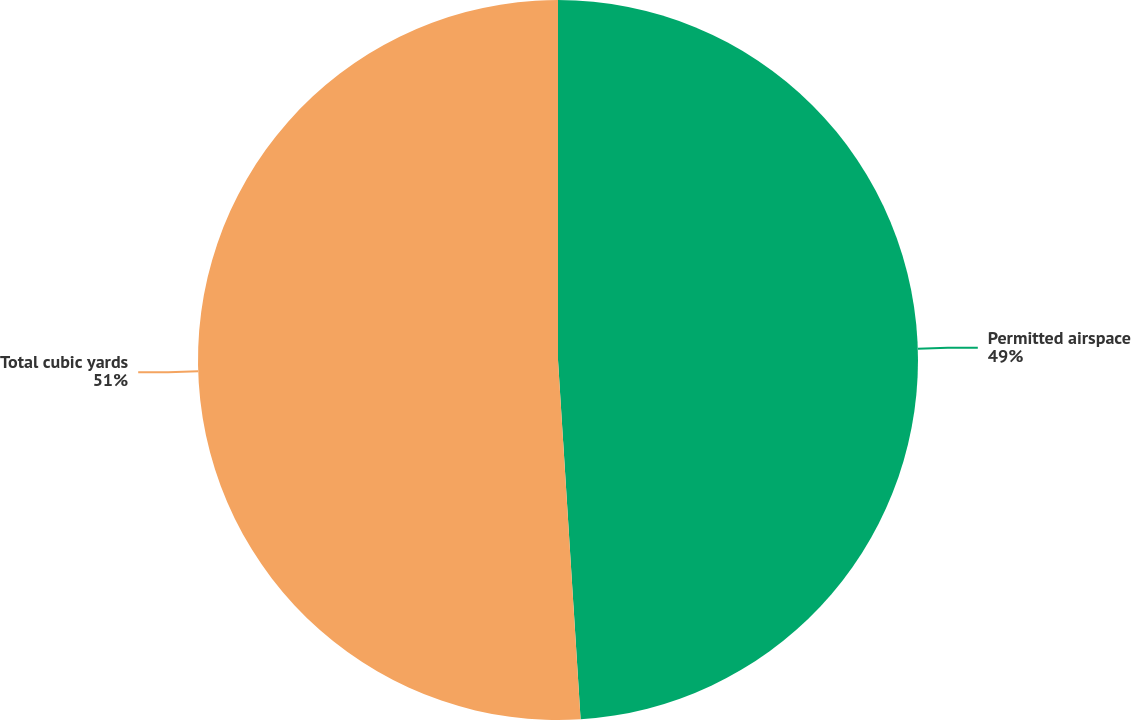Convert chart to OTSL. <chart><loc_0><loc_0><loc_500><loc_500><pie_chart><fcel>Permitted airspace<fcel>Total cubic yards<nl><fcel>49.0%<fcel>51.0%<nl></chart> 